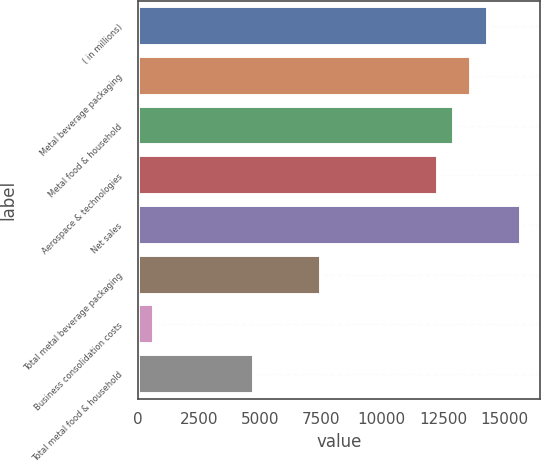<chart> <loc_0><loc_0><loc_500><loc_500><bar_chart><fcel>( in millions)<fcel>Metal beverage packaging<fcel>Metal food & household<fcel>Aerospace & technologies<fcel>Net sales<fcel>Total metal beverage packaging<fcel>Business consolidation costs<fcel>Total metal food & household<nl><fcel>14334.4<fcel>13651.8<fcel>12969.2<fcel>12286.7<fcel>15699.5<fcel>7508.67<fcel>682.97<fcel>4778.39<nl></chart> 